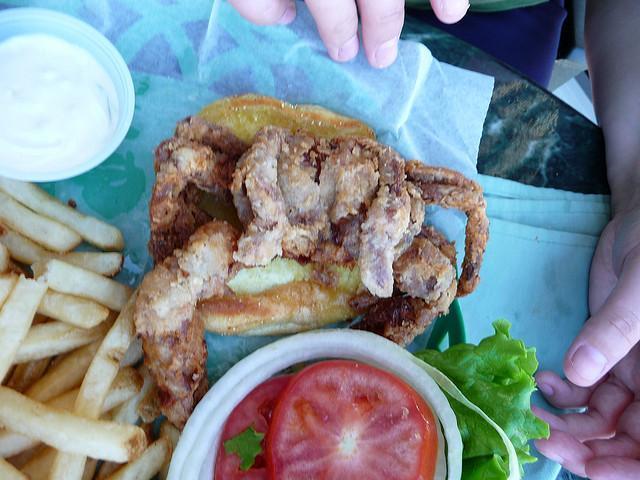What is being dissected here?
From the following set of four choices, select the accurate answer to respond to the question.
Options: Machine, sandwich, frog, table. Sandwich. 